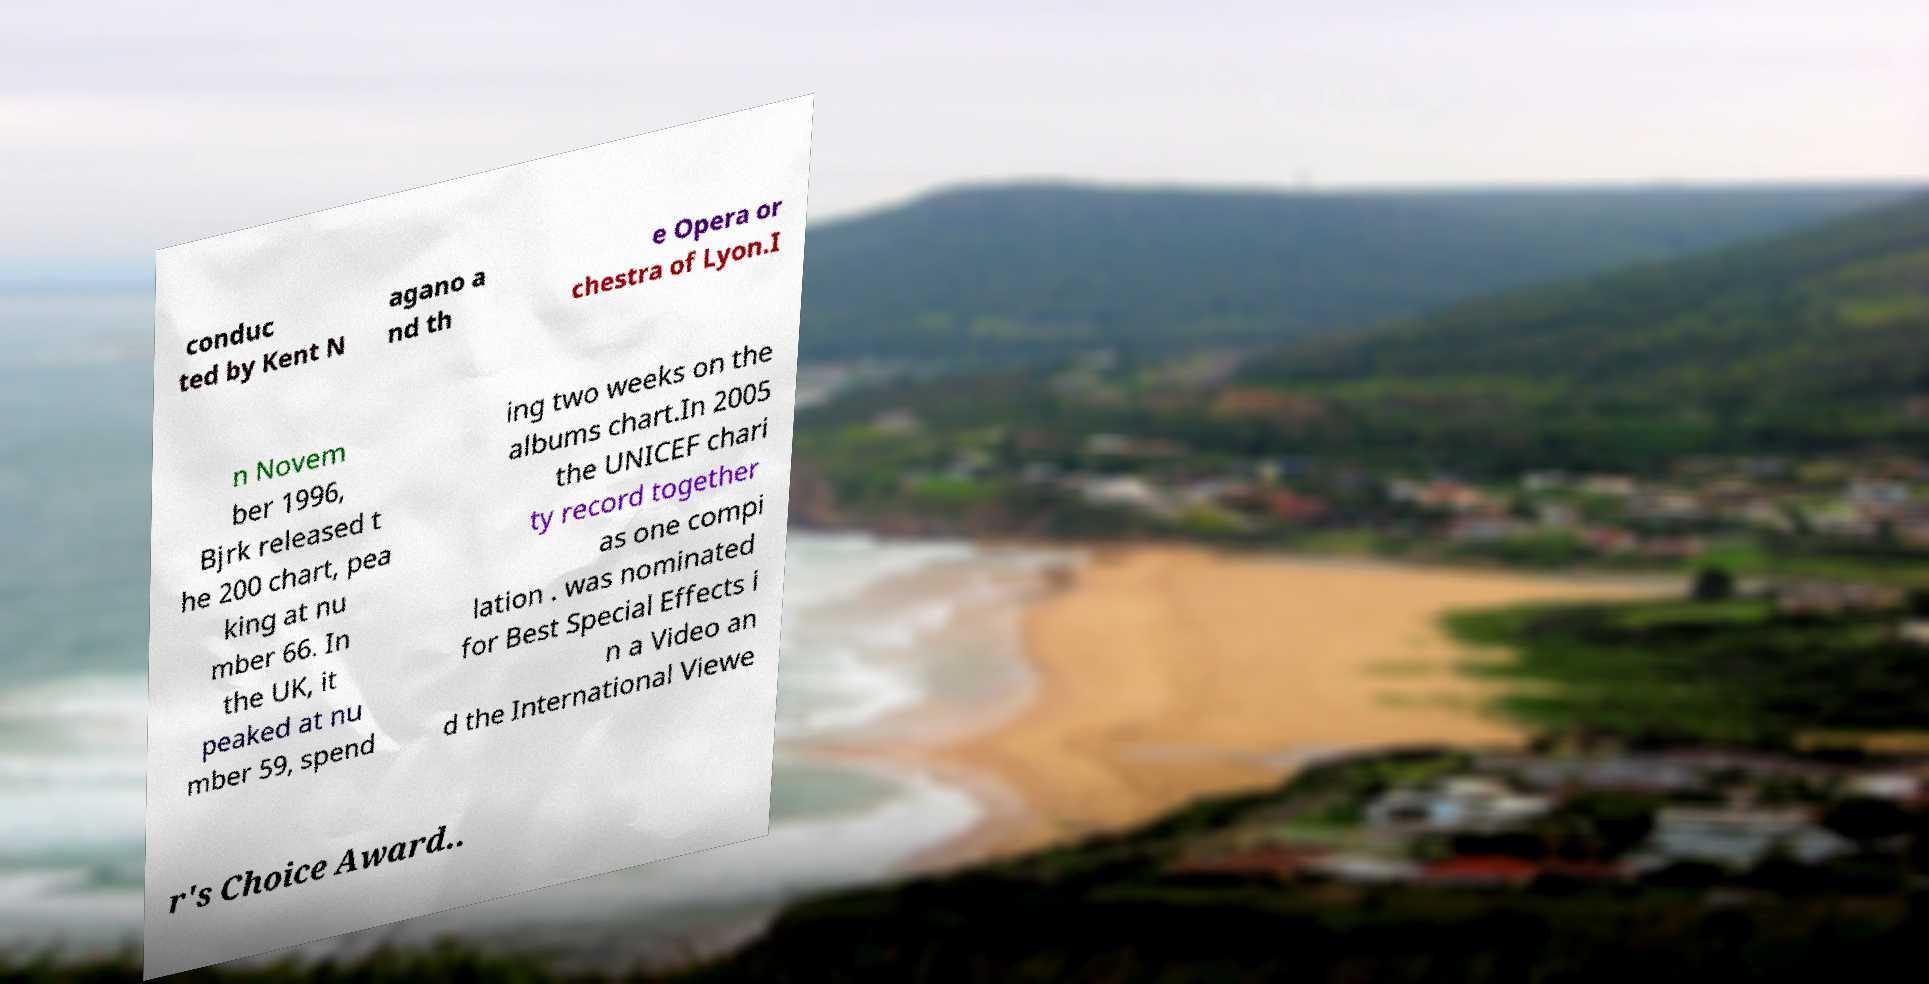Please identify and transcribe the text found in this image. conduc ted by Kent N agano a nd th e Opera or chestra of Lyon.I n Novem ber 1996, Bjrk released t he 200 chart, pea king at nu mber 66. In the UK, it peaked at nu mber 59, spend ing two weeks on the albums chart.In 2005 the UNICEF chari ty record together as one compi lation . was nominated for Best Special Effects i n a Video an d the International Viewe r's Choice Award.. 